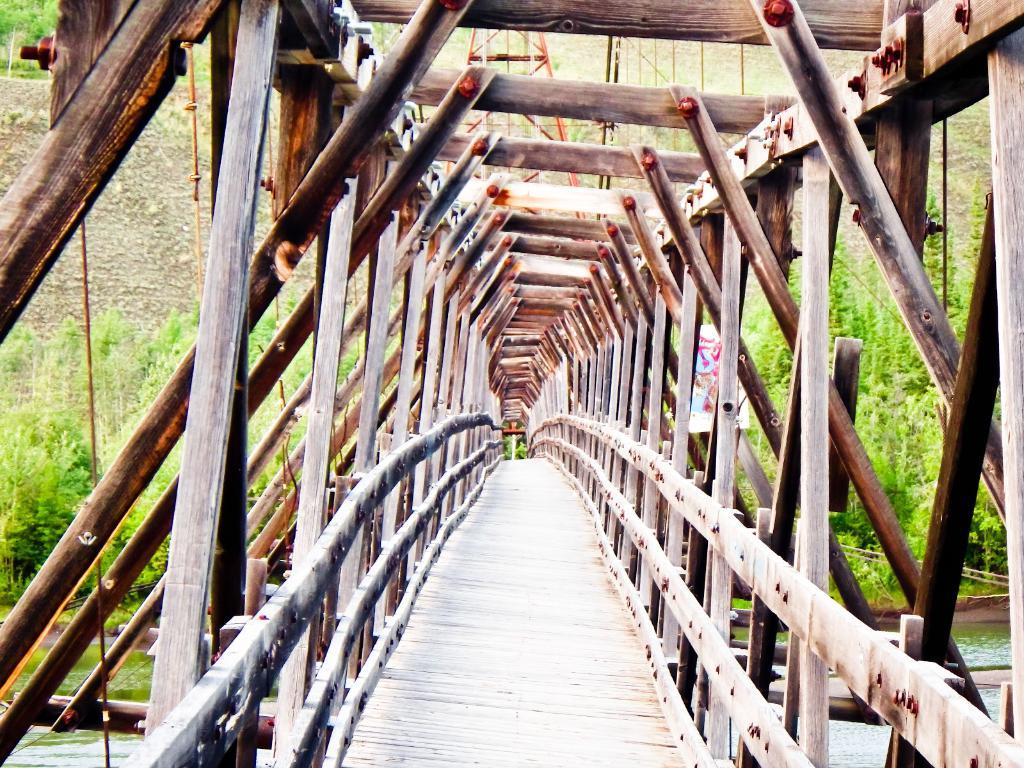What type of seating is present in the image? There is a wooden bench in the image. What natural elements can be seen in the image? There are trees and water visible in the image. Is there any signage or decoration in the image? Yes, there is a small banner in the image. Can you see a window in the image? There is no window present in the image. What type of pump is used to move the water in the image? There is no pump visible in the image; the water is stationary. 